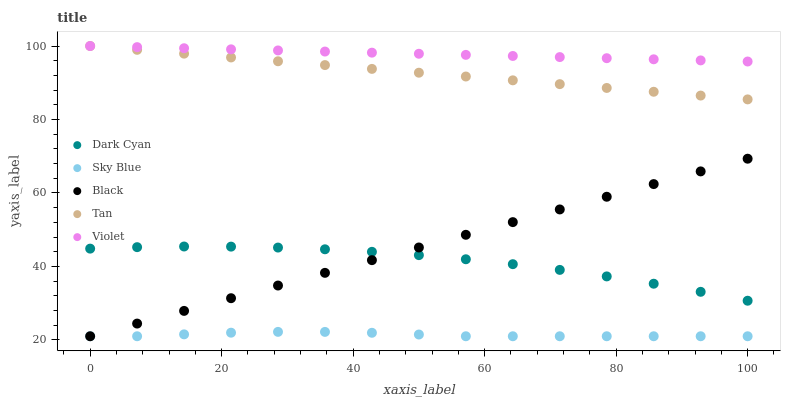Does Sky Blue have the minimum area under the curve?
Answer yes or no. Yes. Does Violet have the maximum area under the curve?
Answer yes or no. Yes. Does Tan have the minimum area under the curve?
Answer yes or no. No. Does Tan have the maximum area under the curve?
Answer yes or no. No. Is Violet the smoothest?
Answer yes or no. Yes. Is Dark Cyan the roughest?
Answer yes or no. Yes. Is Sky Blue the smoothest?
Answer yes or no. No. Is Sky Blue the roughest?
Answer yes or no. No. Does Sky Blue have the lowest value?
Answer yes or no. Yes. Does Tan have the lowest value?
Answer yes or no. No. Does Violet have the highest value?
Answer yes or no. Yes. Does Sky Blue have the highest value?
Answer yes or no. No. Is Black less than Violet?
Answer yes or no. Yes. Is Tan greater than Black?
Answer yes or no. Yes. Does Black intersect Dark Cyan?
Answer yes or no. Yes. Is Black less than Dark Cyan?
Answer yes or no. No. Is Black greater than Dark Cyan?
Answer yes or no. No. Does Black intersect Violet?
Answer yes or no. No. 